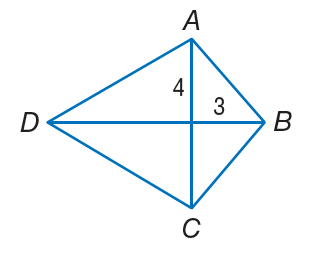Question: If A B C D is a kite, find A B.
Choices:
A. 3
B. 4
C. 5
D. 7
Answer with the letter. Answer: C 